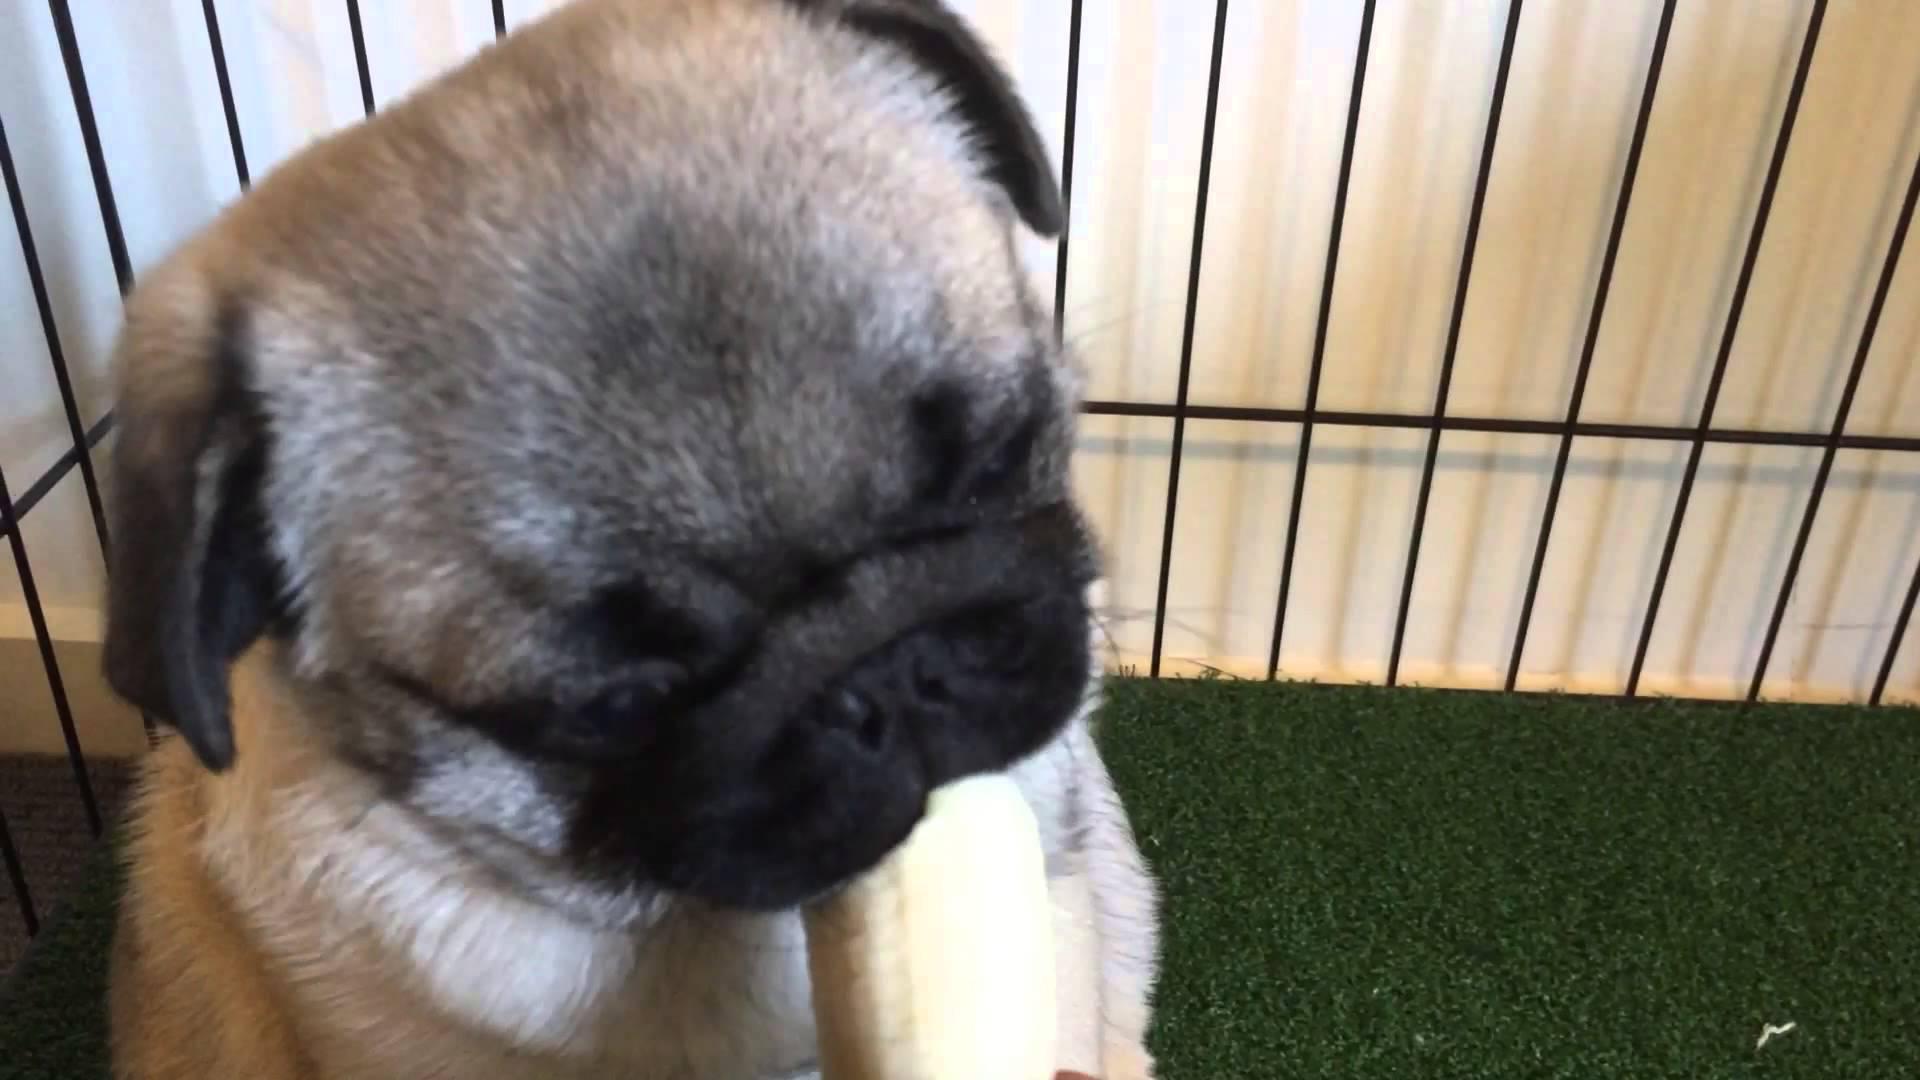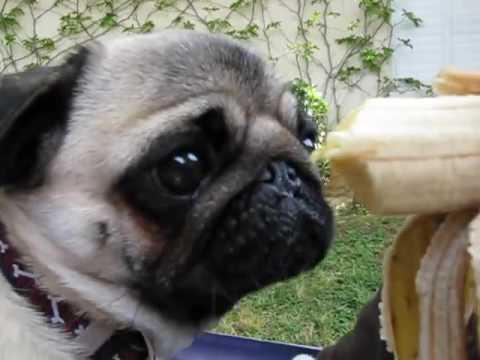The first image is the image on the left, the second image is the image on the right. Considering the images on both sides, is "All dogs shown are outdoors, and a hand is visible reaching from the right to offer a pug a banana in one image." valid? Answer yes or no. No. The first image is the image on the left, the second image is the image on the right. Examine the images to the left and right. Is the description "The dog in the image on the right is being offered a banana." accurate? Answer yes or no. Yes. 